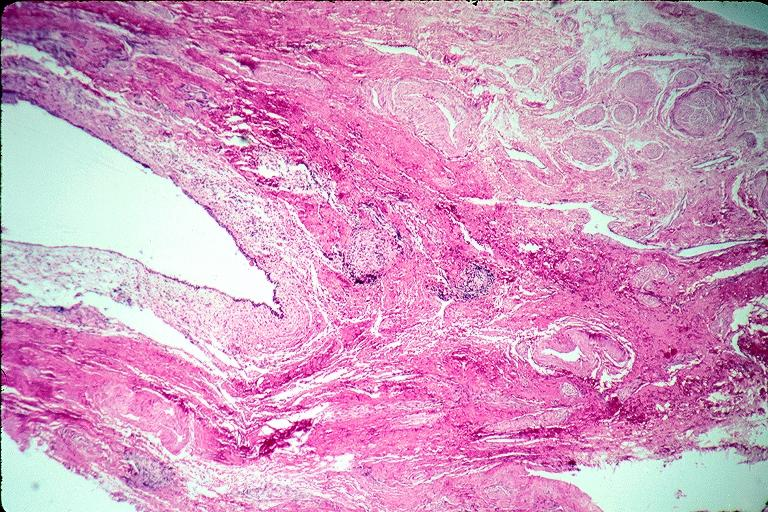does pulmonary osteoarthropathy show incisive canal cyst nasopalatien duct cyst?
Answer the question using a single word or phrase. No 